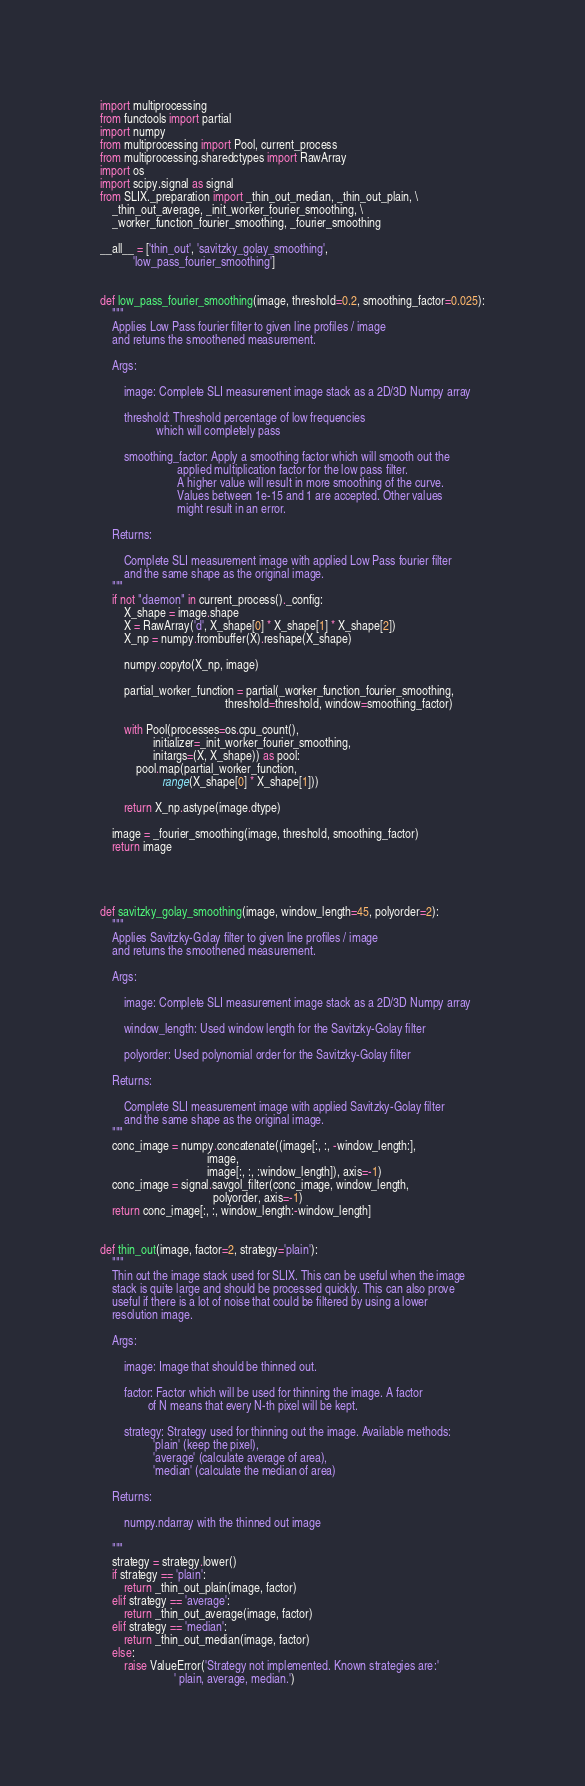<code> <loc_0><loc_0><loc_500><loc_500><_Python_>import multiprocessing
from functools import partial
import numpy
from multiprocessing import Pool, current_process
from multiprocessing.sharedctypes import RawArray
import os
import scipy.signal as signal
from SLIX._preparation import _thin_out_median, _thin_out_plain, \
    _thin_out_average, _init_worker_fourier_smoothing, \
    _worker_function_fourier_smoothing, _fourier_smoothing

__all__ = ['thin_out', 'savitzky_golay_smoothing',
           'low_pass_fourier_smoothing']


def low_pass_fourier_smoothing(image, threshold=0.2, smoothing_factor=0.025):
    """
    Applies Low Pass fourier filter to given line profiles / image
    and returns the smoothened measurement.

    Args:

        image: Complete SLI measurement image stack as a 2D/3D Numpy array

        threshold: Threshold percentage of low frequencies
                   which will completely pass

        smoothing_factor: Apply a smoothing factor which will smooth out the 
                          applied multiplication factor for the low pass filter.
                          A higher value will result in more smoothing of the curve.
                          Values between 1e-15 and 1 are accepted. Other values 
                          might result in an error.

    Returns:

        Complete SLI measurement image with applied Low Pass fourier filter
        and the same shape as the original image.
    """
    if not "daemon" in current_process()._config:
        X_shape = image.shape
        X = RawArray('d', X_shape[0] * X_shape[1] * X_shape[2])
        X_np = numpy.frombuffer(X).reshape(X_shape)

        numpy.copyto(X_np, image)

        partial_worker_function = partial(_worker_function_fourier_smoothing,
                                          threshold=threshold, window=smoothing_factor)

        with Pool(processes=os.cpu_count(),
                  initializer=_init_worker_fourier_smoothing,
                  initargs=(X, X_shape)) as pool:
            pool.map(partial_worker_function,
                     range(X_shape[0] * X_shape[1]))

        return X_np.astype(image.dtype)

    image = _fourier_smoothing(image, threshold, smoothing_factor)
    return image




def savitzky_golay_smoothing(image, window_length=45, polyorder=2):
    """
    Applies Savitzky-Golay filter to given line profiles / image
    and returns the smoothened measurement.

    Args:

        image: Complete SLI measurement image stack as a 2D/3D Numpy array

        window_length: Used window length for the Savitzky-Golay filter

        polyorder: Used polynomial order for the Savitzky-Golay filter

    Returns:

        Complete SLI measurement image with applied Savitzky-Golay filter
        and the same shape as the original image.
    """
    conc_image = numpy.concatenate((image[:, :, -window_length:],
                                    image,
                                    image[:, :, :window_length]), axis=-1)
    conc_image = signal.savgol_filter(conc_image, window_length,
                                      polyorder, axis=-1)
    return conc_image[:, :, window_length:-window_length]


def thin_out(image, factor=2, strategy='plain'):
    """
    Thin out the image stack used for SLIX. This can be useful when the image
    stack is quite large and should be processed quickly. This can also prove
    useful if there is a lot of noise that could be filtered by using a lower
    resolution image.

    Args:

        image: Image that should be thinned out.

        factor: Factor which will be used for thinning the image. A factor
                of N means that every N-th pixel will be kept.

        strategy: Strategy used for thinning out the image. Available methods:
                  'plain' (keep the pixel),
                  'average' (calculate average of area),
                  'median' (calculate the median of area)

    Returns:

        numpy.ndarray with the thinned out image

    """
    strategy = strategy.lower()
    if strategy == 'plain':
        return _thin_out_plain(image, factor)
    elif strategy == 'average':
        return _thin_out_average(image, factor)
    elif strategy == 'median':
        return _thin_out_median(image, factor)
    else:
        raise ValueError('Strategy not implemented. Known strategies are:'
                         ' plain, average, median.')
</code> 